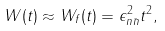Convert formula to latex. <formula><loc_0><loc_0><loc_500><loc_500>W ( t ) \approx W _ { f } ( t ) = \epsilon _ { n \bar { n } } ^ { 2 } t ^ { 2 } ,</formula> 